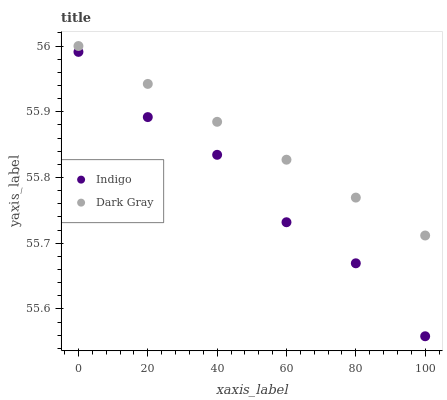Does Indigo have the minimum area under the curve?
Answer yes or no. Yes. Does Dark Gray have the maximum area under the curve?
Answer yes or no. Yes. Does Indigo have the maximum area under the curve?
Answer yes or no. No. Is Dark Gray the smoothest?
Answer yes or no. Yes. Is Indigo the roughest?
Answer yes or no. Yes. Is Indigo the smoothest?
Answer yes or no. No. Does Indigo have the lowest value?
Answer yes or no. Yes. Does Dark Gray have the highest value?
Answer yes or no. Yes. Does Indigo have the highest value?
Answer yes or no. No. Is Indigo less than Dark Gray?
Answer yes or no. Yes. Is Dark Gray greater than Indigo?
Answer yes or no. Yes. Does Indigo intersect Dark Gray?
Answer yes or no. No. 